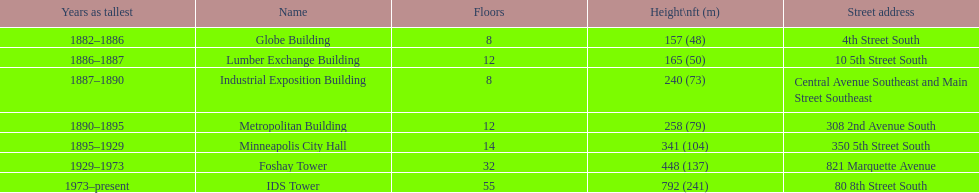How many buildings on the list are taller than 200 feet? 5. Parse the table in full. {'header': ['Years as tallest', 'Name', 'Floors', 'Height\\nft (m)', 'Street address'], 'rows': [['1882–1886', 'Globe Building', '8', '157 (48)', '4th Street South'], ['1886–1887', 'Lumber Exchange Building', '12', '165 (50)', '10 5th Street South'], ['1887–1890', 'Industrial Exposition Building', '8', '240 (73)', 'Central Avenue Southeast and Main Street Southeast'], ['1890–1895', 'Metropolitan Building', '12', '258 (79)', '308 2nd Avenue South'], ['1895–1929', 'Minneapolis City Hall', '14', '341 (104)', '350 5th Street South'], ['1929–1973', 'Foshay Tower', '32', '448 (137)', '821 Marquette Avenue'], ['1973–present', 'IDS Tower', '55', '792 (241)', '80 8th Street South']]} 